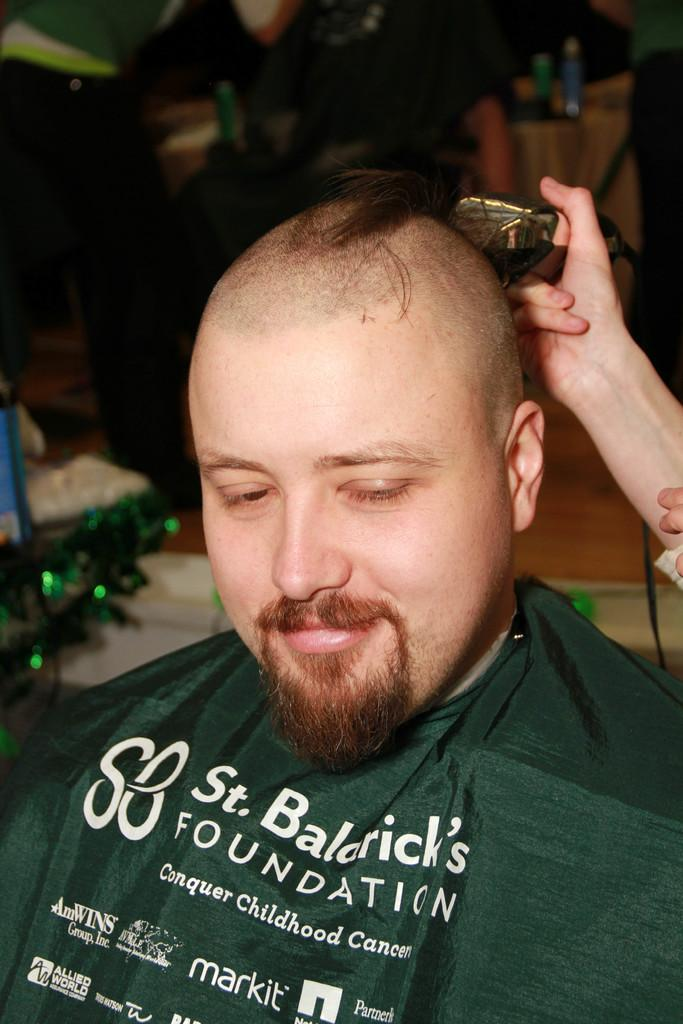What is the expression of one person in the image? One person is smiling. What is the other person holding in the image? The other person is holding a trimmer. Can you describe the background of the image? The background is blurred. What objects can be seen in the image besides the people? There are bottles visible in the image. How many people are in the image? There are two people in the image. What type of butter is being used to grease the cart in the image? There is no butter or cart present in the image. What kind of wood is visible in the image? There is no wood visible in the image. 